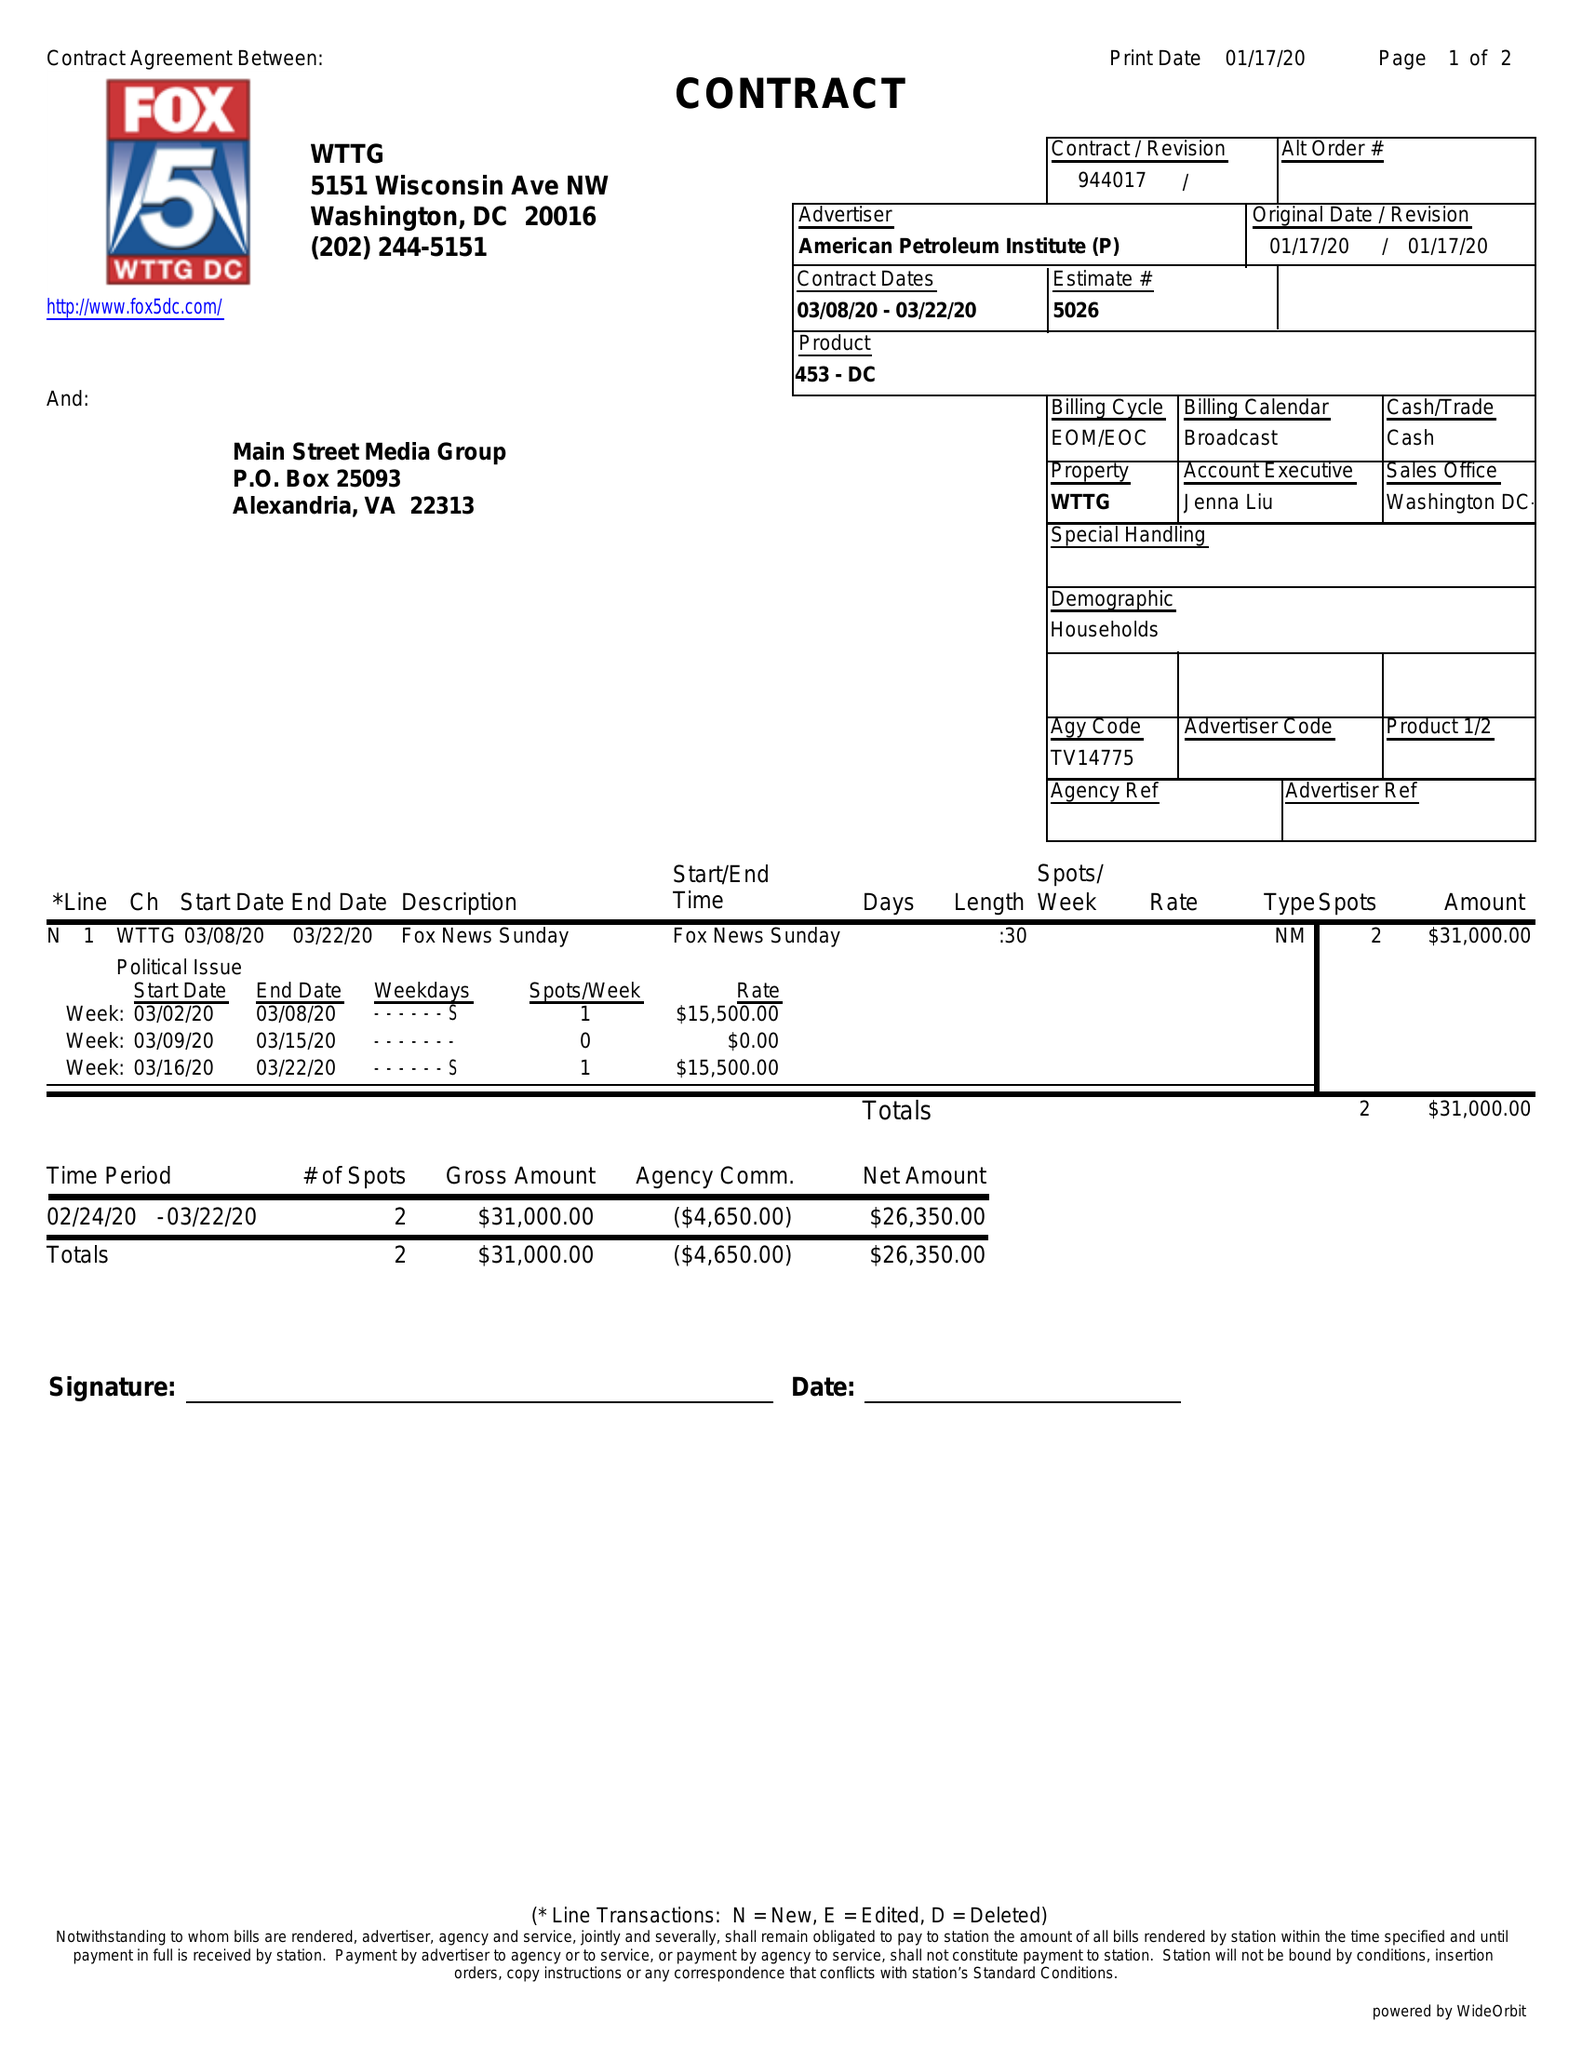What is the value for the flight_to?
Answer the question using a single word or phrase. 03/22/20 